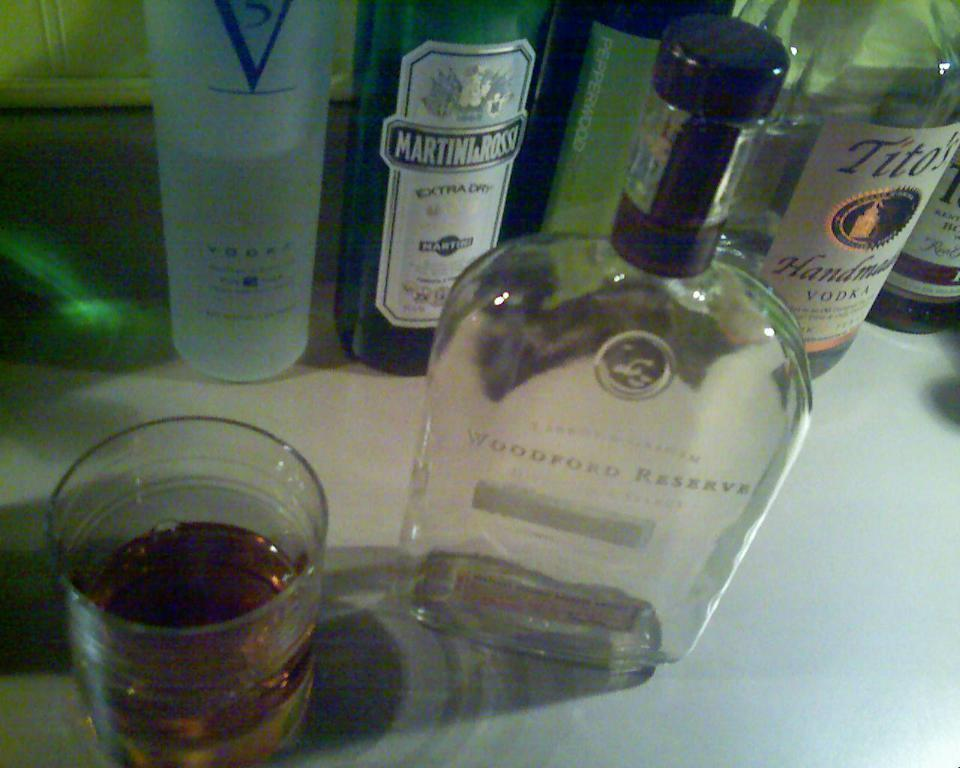<image>
Relay a brief, clear account of the picture shown. Some bottles of alcohol, one of which has Extra Dry written on it. 